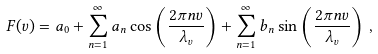Convert formula to latex. <formula><loc_0><loc_0><loc_500><loc_500>F ( v ) = a _ { 0 } + \sum _ { n = 1 } ^ { \infty } a _ { n } \cos \left ( \frac { 2 \pi n v } { \lambda _ { v } } \right ) + \sum _ { n = 1 } ^ { \infty } b _ { n } \sin \left ( \frac { 2 \pi n v } { \lambda _ { v } } \right ) \, ,</formula> 